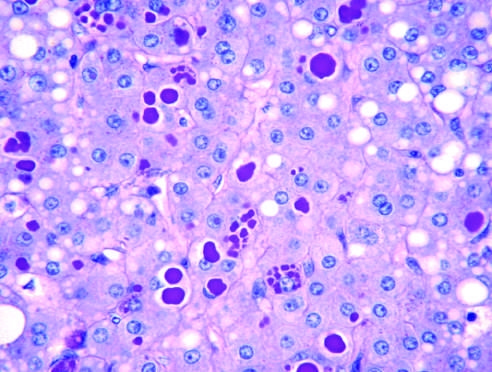does periodic acid-schiff stain after diastase digestion of the liver?
Answer the question using a single word or phrase. Yes 